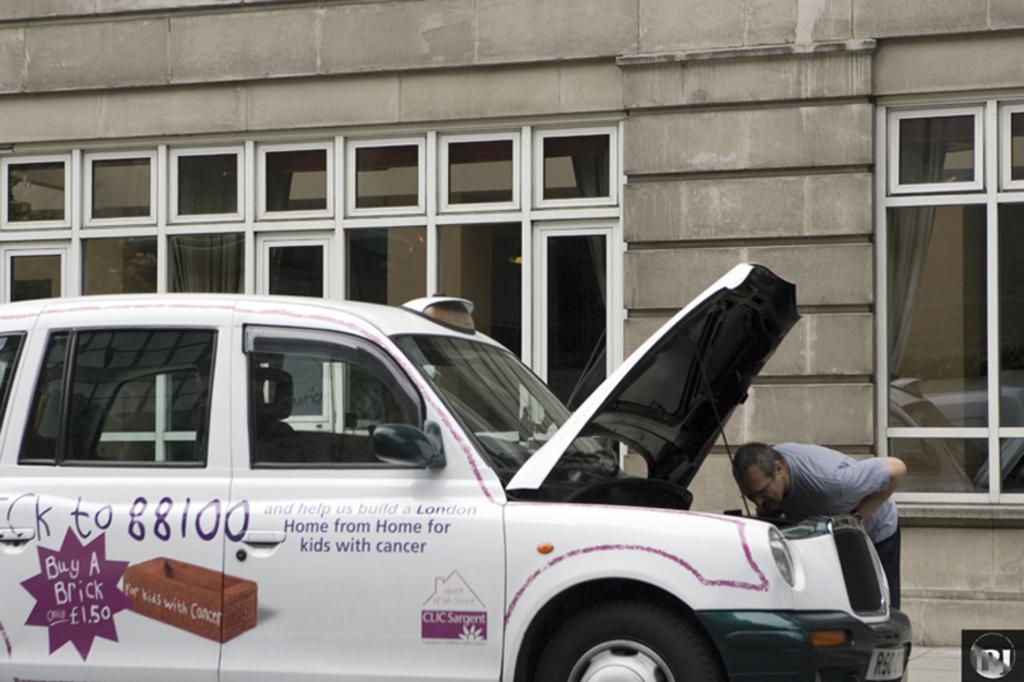For whom they sell a brick at low cost?
Your response must be concise. Kids with cancer. How much does a brick cost according to the decal on the car?
Make the answer very short. 1.50. 